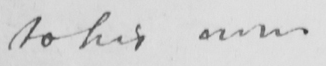Can you read and transcribe this handwriting? to his own 